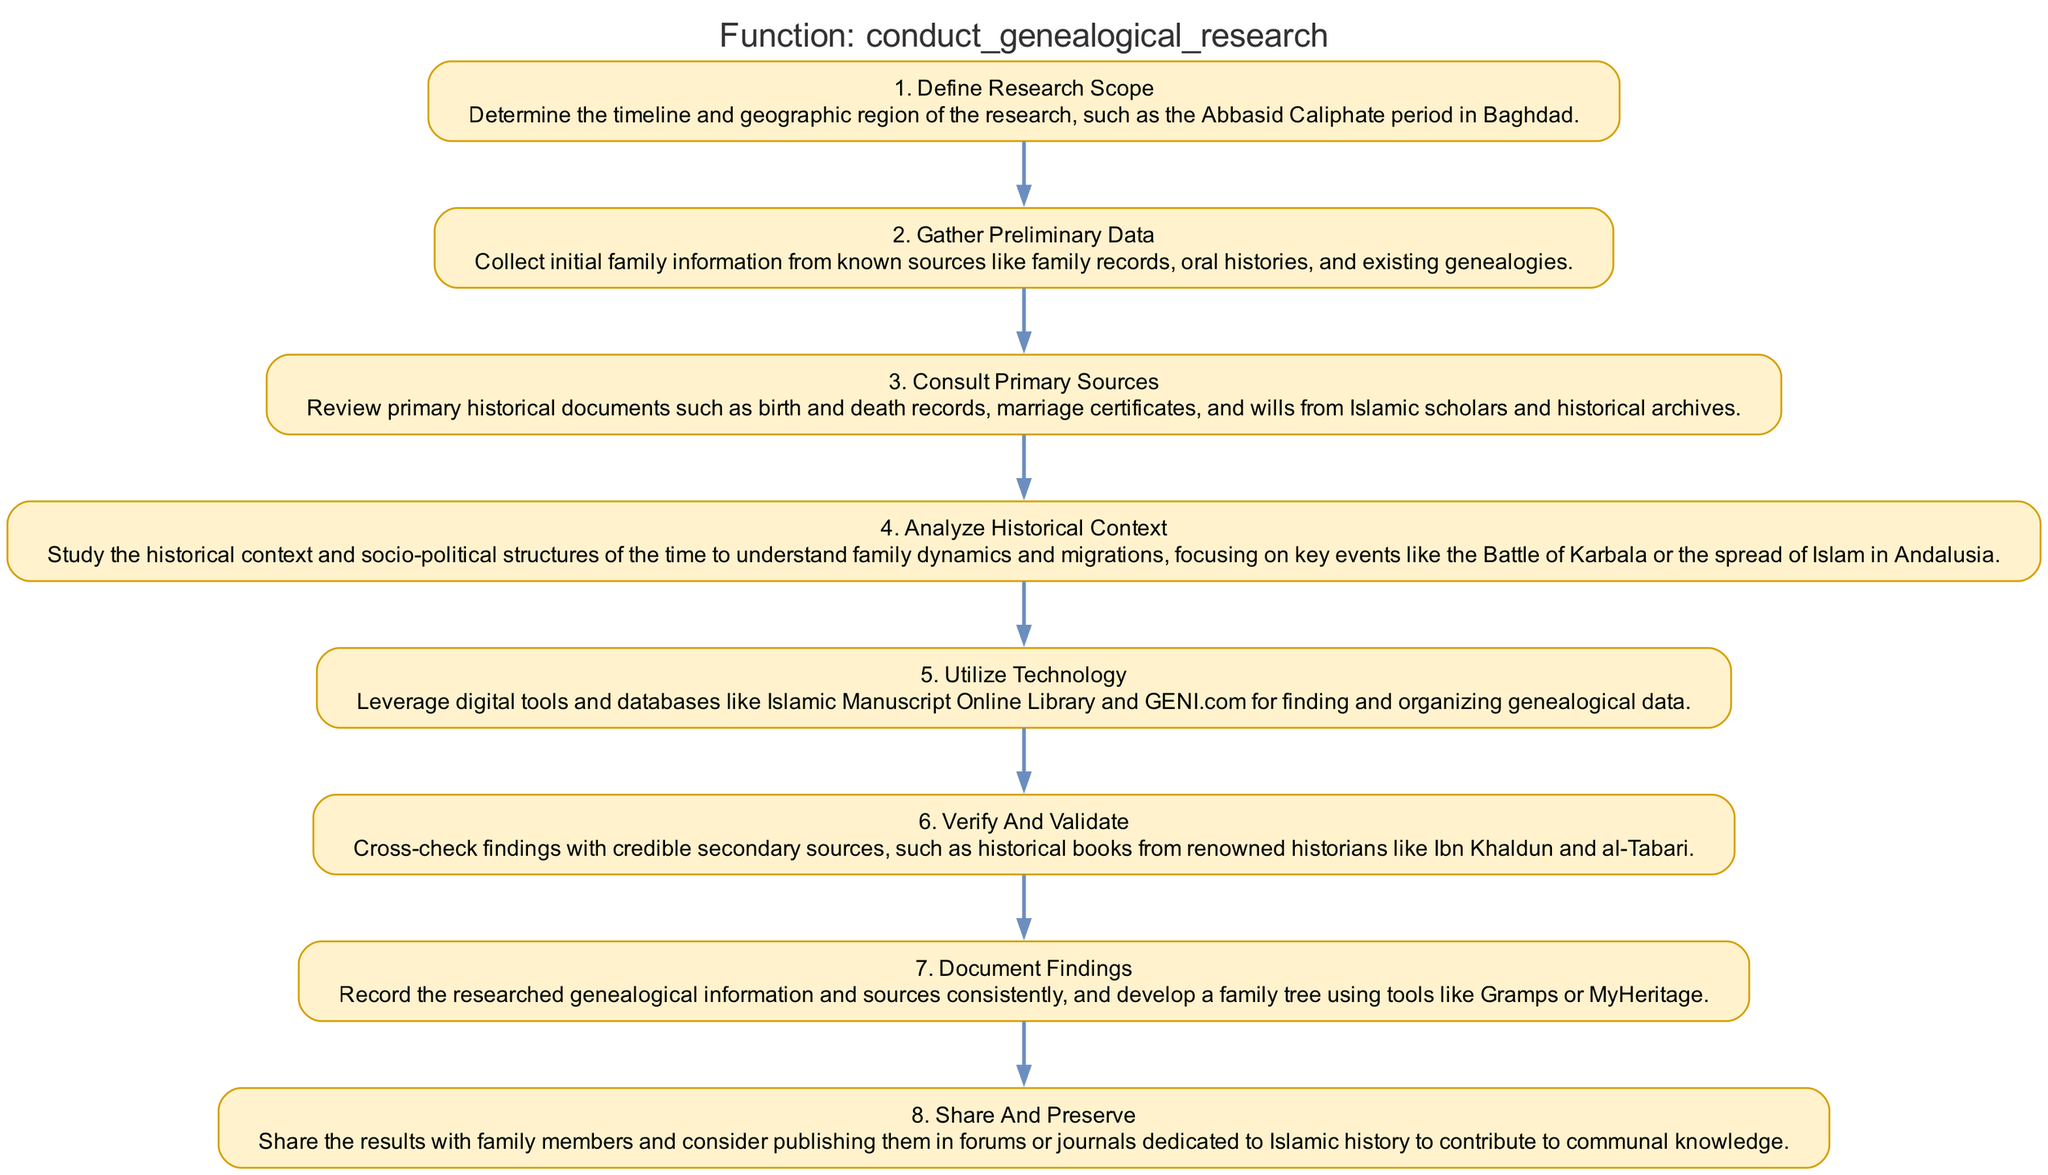What is the first step in conducting genealogical research? The diagram indicates that the first step is "Define Research Scope," which involves determining the timeline and geographic region of the research.
Answer: Define Research Scope How many steps are involved in the genealogical research process? By counting the nodes in the diagram, we see that there are a total of eight steps indicated in the process.
Answer: Eight Which step comes after "Gather Preliminary Data"? "Consult Primary Sources" follows "Gather Preliminary Data" as the second step in the diagram, focusing on reviewing historical documents.
Answer: Consult Primary Sources What is the last step outlined for genealogical research? The last step in the flowchart is "Share and Preserve," emphasizing the importance of sharing findings with family and communities.
Answer: Share and Preserve Which two steps focus on verifying the research findings? The steps "Verify and Validate" and "Document Findings" both emphasize the importance of ensuring the accuracy of the research and properly recording the information obtained.
Answer: Verify and Validate; Document Findings How many primary sources are specifically mentioned in the third step? The third step lists three examples of primary sources: birth records, marriage certificates, and wills, which focus on collecting historical data.
Answer: Three What action is taken in the fifth step, "Utilize Technology"? The fifth step involves leveraging digital tools and databases like the Islamic Manuscript Online Library and GENI.com to assist in finding and organizing genealogical data.
Answer: Leverage digital tools Which historical events are suggested for analysis in the fourth step? The fourth step highlights key events such as the Battle of Karbala and the spread of Islam in Andalusia as important contexts for understanding genealogical research.
Answer: Battle of Karbala; spread of Islam in Andalusia 